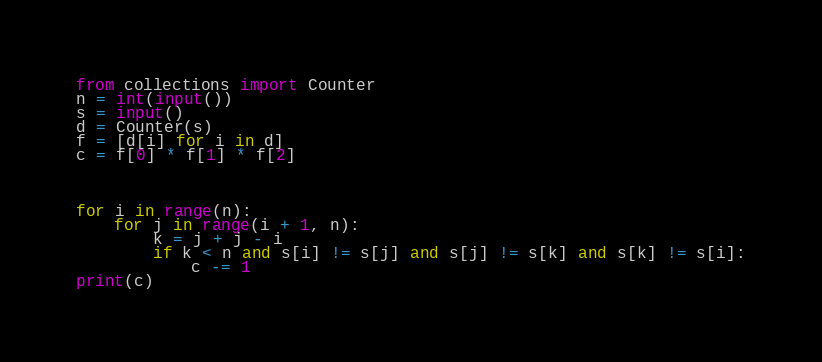Convert code to text. <code><loc_0><loc_0><loc_500><loc_500><_Python_>
from collections import Counter
n = int(input())
s = input()
d = Counter(s)
f = [d[i] for i in d]
c = f[0] * f[1] * f[2]
 


for i in range(n):
    for j in range(i + 1, n):
        k = j + j - i
        if k < n and s[i] != s[j] and s[j] != s[k] and s[k] != s[i]:
            c -= 1
print(c)            </code> 